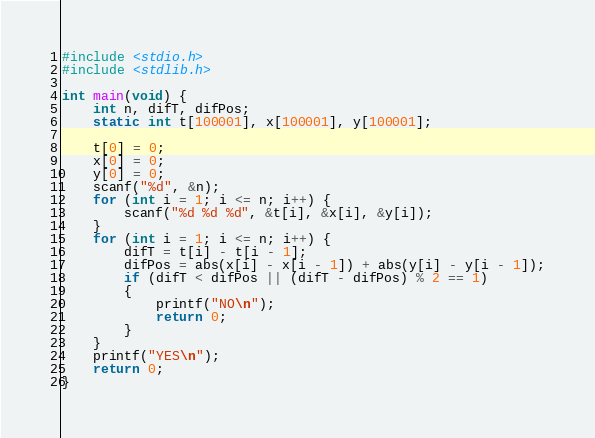<code> <loc_0><loc_0><loc_500><loc_500><_C_>#include <stdio.h>
#include <stdlib.h>

int main(void) {
	int n, difT, difPos;
	static int t[100001], x[100001], y[100001];

	t[0] = 0;
	x[0] = 0;
	y[0] = 0;
	scanf("%d", &n);
	for (int i = 1; i <= n; i++) {
		scanf("%d %d %d", &t[i], &x[i], &y[i]);
	}
	for (int i = 1; i <= n; i++) {
		difT = t[i] - t[i - 1];
		difPos = abs(x[i] - x[i - 1]) + abs(y[i] - y[i - 1]);
		if (difT < difPos || (difT - difPos) % 2 == 1)
		{
			printf("NO\n");
			return 0;
		}
	}
	printf("YES\n");
	return 0;
}
</code> 